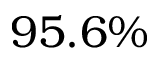<formula> <loc_0><loc_0><loc_500><loc_500>9 5 . 6 \%</formula> 